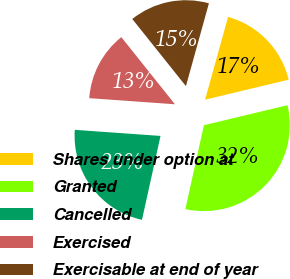Convert chart to OTSL. <chart><loc_0><loc_0><loc_500><loc_500><pie_chart><fcel>Shares under option at<fcel>Granted<fcel>Cancelled<fcel>Exercised<fcel>Exercisable at end of year<nl><fcel>16.95%<fcel>32.2%<fcel>22.67%<fcel>13.14%<fcel>15.04%<nl></chart> 